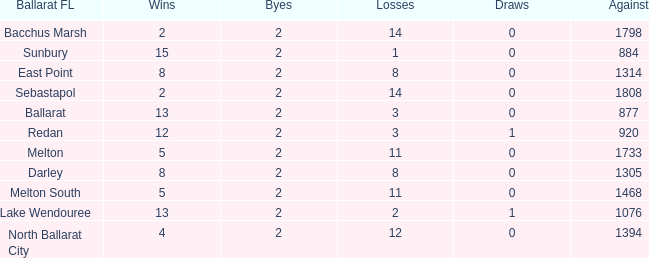How many Losses have a Ballarat FL of melton south, and an Against larger than 1468? 0.0. Could you parse the entire table? {'header': ['Ballarat FL', 'Wins', 'Byes', 'Losses', 'Draws', 'Against'], 'rows': [['Bacchus Marsh', '2', '2', '14', '0', '1798'], ['Sunbury', '15', '2', '1', '0', '884'], ['East Point', '8', '2', '8', '0', '1314'], ['Sebastapol', '2', '2', '14', '0', '1808'], ['Ballarat', '13', '2', '3', '0', '877'], ['Redan', '12', '2', '3', '1', '920'], ['Melton', '5', '2', '11', '0', '1733'], ['Darley', '8', '2', '8', '0', '1305'], ['Melton South', '5', '2', '11', '0', '1468'], ['Lake Wendouree', '13', '2', '2', '1', '1076'], ['North Ballarat City', '4', '2', '12', '0', '1394']]} 